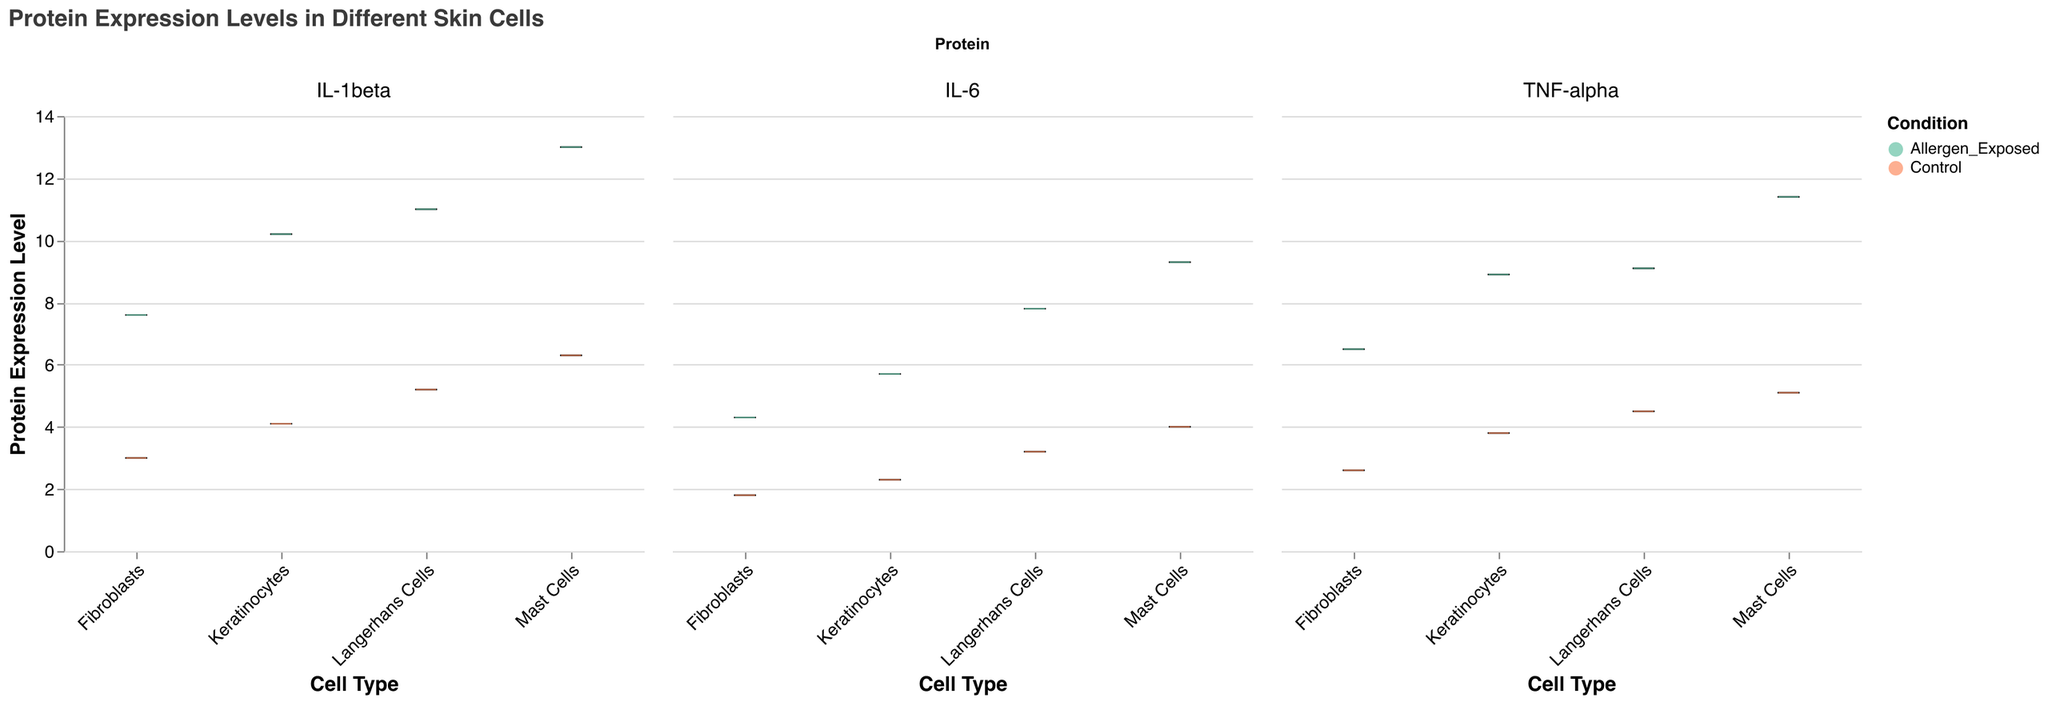What is the title of the figure? The title is usually placed at the top of the figure in a larger font and is often descriptive of the content shown in the figure. In this case, the title is directly given in the `title` field.
Answer: Protein Expression Levels in Different Skin Cells Which cell type has the highest median protein expression level when exposed to allergens? In a notched box plot, the line inside the box represents the median value. By comparing the median lines across different cell types, the Mast Cells have the highest median protein expression level when exposed to allergens.
Answer: Mast Cells What is the maximum protein expression level for IL-1beta in Mast Cells when exposed to allergens? The whiskers of the box plot represent the range of the data, and the top whisker shows the maximum value. By locating the IL-1beta column and the Mast Cells row, the top whisker represents the maximum expression level.
Answer: 13.0 How does the expression level of IL-6 in Keratinocytes change from control to allergen exposed conditions? To determine the change, compare the position of the medians for the control and allergen-exposed conditions for IL-6 in Keratinocytes. The median increases from control to allergen-exposed condition.
Answer: Increase Between IL-6 and TNF-alpha proteins, which shows a larger increase in expression levels from control to allergen-exposed in Fibroblasts? Compare the difference in median values of IL-6 and TNF-alpha in Fibroblasts from control to allergen-exposed conditions by examining the median lines in each box. IL-6 increases from 1.8 to 4.3, and TNF-alpha increases from 2.6 to 6.5. TNF-alpha shows a larger increase.
Answer: TNF-alpha How many different proteins are shown in the figure? The figure contains separate columns for each protein type. By counting the distinct columns, we can determine the number of different proteins shown.
Answer: Three (IL-6, TNF-alpha, IL-1beta) Which cell type shows the least increase in IL-1beta protein expression when exposed to allergens compared to control? To find this, compare the increases in the median expression levels of IL-1beta across different cell types from control to allergen-exposed conditions. Keratinocytes show an increase from 4.1 to 10.2, Langerhans Cells show an increase from 5.2 to 11.0, Fibroblasts from 3.0 to 7.6, and Mast Cells from 6.3 to 13.0. Fibroblasts show the least increase.
Answer: Fibroblasts 